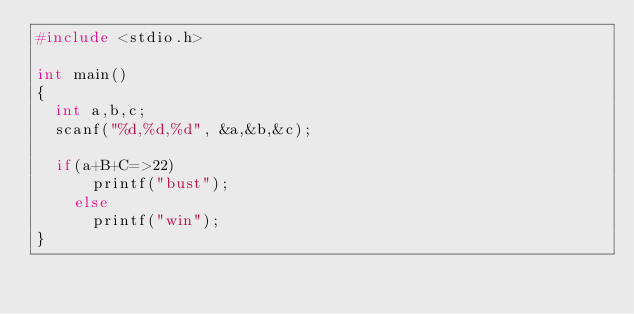Convert code to text. <code><loc_0><loc_0><loc_500><loc_500><_C_>#include <stdio.h>
 
int main()
{
	int a,b,c;
	scanf("%d,%d,%d", &a,&b,&c);
 
	if(a+B+C=>22)
      printf("bust");
    else
      printf("win");
}</code> 